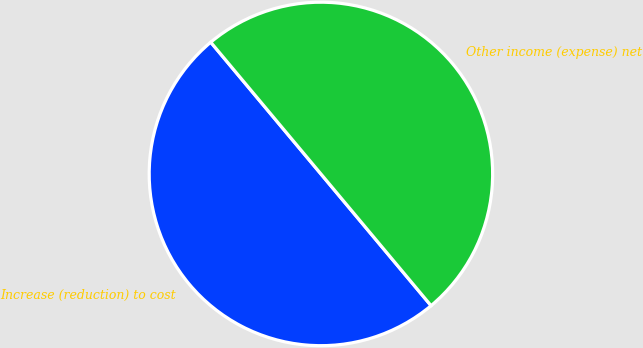<chart> <loc_0><loc_0><loc_500><loc_500><pie_chart><fcel>Increase (reduction) to cost<fcel>Other income (expense) net<nl><fcel>50.0%<fcel>50.0%<nl></chart> 